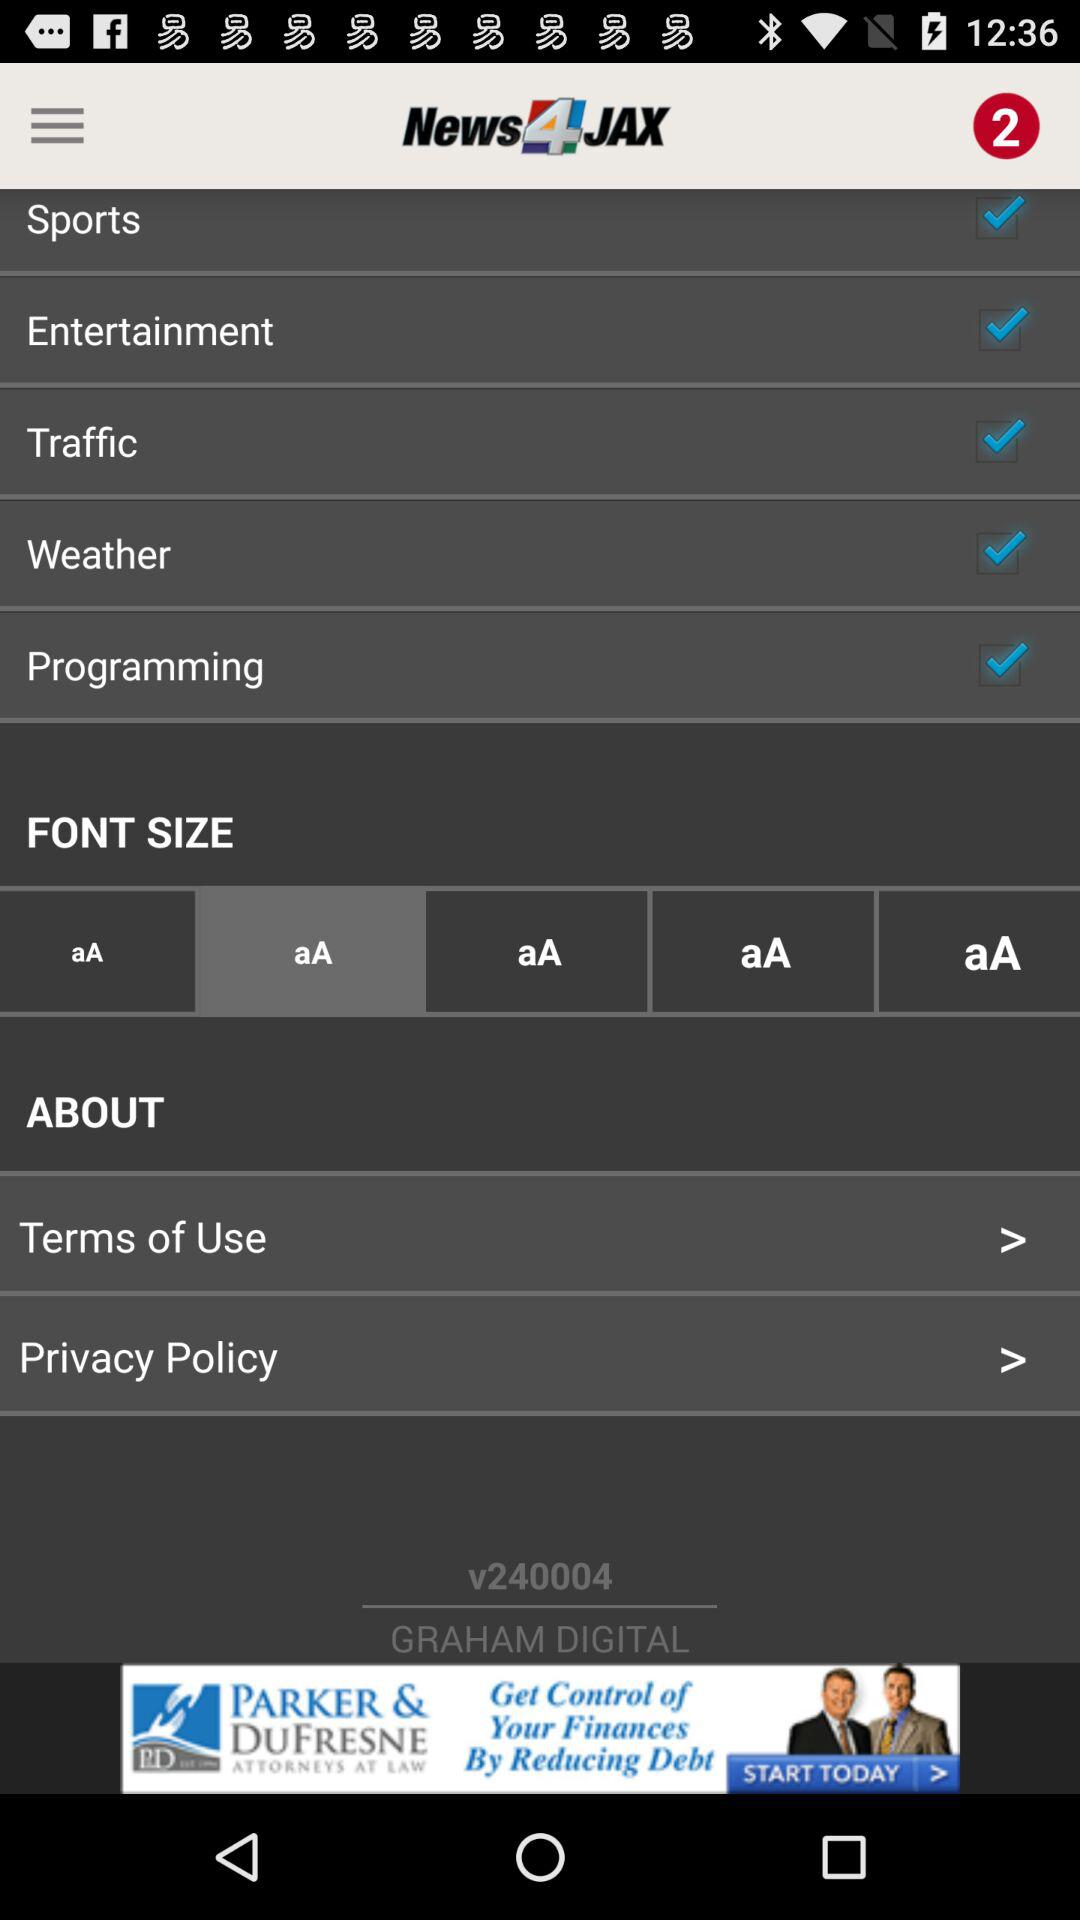What is the name of the application? The name of the application is "News4JAX". 